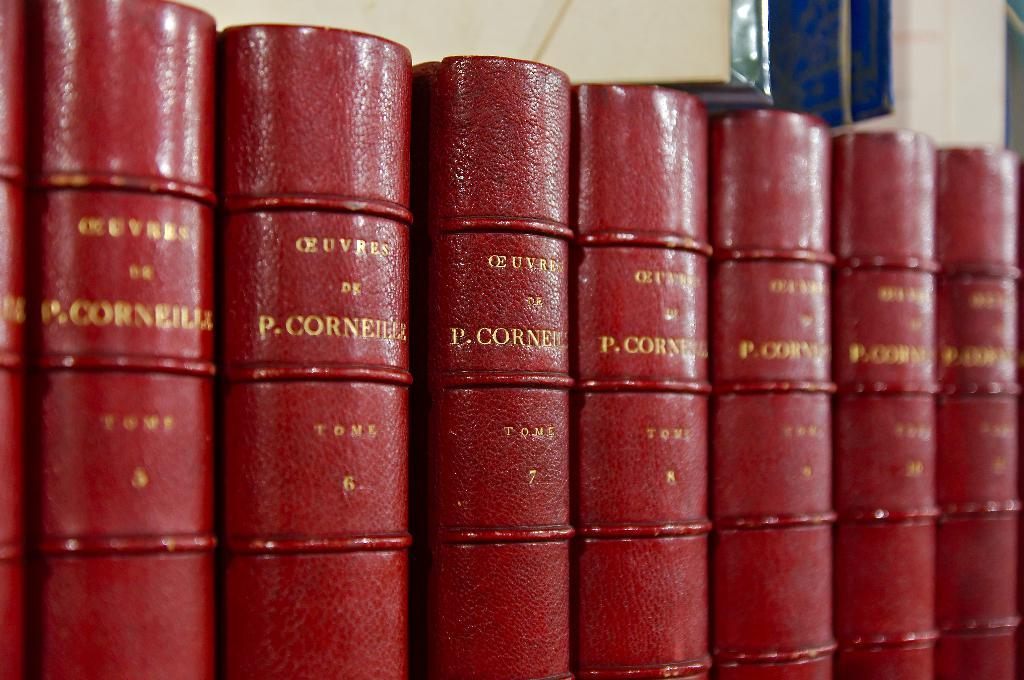Provide a one-sentence caption for the provided image. A row of books by P. Corneilla stand side by side. 